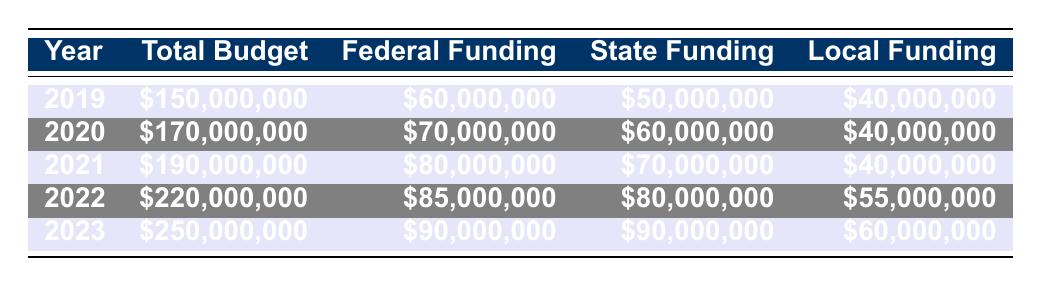What was the total budget for STEM programming in 2021? The table shows the total budget for each year listed. For 2021, the total budget is \$190,000,000.
Answer: \$190,000,000 What was the federal funding amount in 2023? According to the table, the federal funding for the year 2023 is listed as \$90,000,000.
Answer: \$90,000,000 Which year had the lowest local funding? By examining the local funding values in the table, the lowest local funding is in 2019, which is \$40,000,000.
Answer: 2019 What is the difference between federal funding in 2022 and 2021? The federal funding for 2022 is \$85,000,000 and for 2021 is \$80,000,000. The difference is \$85,000,000 - \$80,000,000 = \$5,000,000.
Answer: \$5,000,000 What is the average total budget over the five years? The total budgets for the five years are \$150,000,000, \$170,000,000, \$190,000,000, \$220,000,000, and \$250,000,000. Adding these gives \$1,080,000,000. Dividing by 5 gives an average of \$216,000,000.
Answer: \$216,000,000 Has federal funding increased every year? By comparing federal funding amounts from 2019 to 2023 in the table: \$60,000,000 (2019), \$70,000,000 (2020), \$80,000,000 (2021), \$85,000,000 (2022), and \$90,000,000 (2023), we see an increase each year. Therefore, the statement is true.
Answer: Yes Which funding source had the highest amount in 2020? In 2020, the funding amounts are federal: \$70,000,000, state: \$60,000,000, and local: \$40,000,000. The highest among these is the federal funding of \$70,000,000.
Answer: Federal Funding What is the percentage increase in the total budget from 2019 to 2023? The total budget in 2019 is \$150,000,000 and in 2023 is \$250,000,000. The increase is \$250,000,000 - \$150,000,000 = \$100,000,000. The percentage increase is (\$100,000,000 / \$150,000,000) * 100 = 66.67%.
Answer: 66.67% What is the local funding for 2022 and how does it compare to federal funding in the same year? The local funding for 2022 is \$55,000,000 and federal funding is \$85,000,000. Comparing these, \$85,000,000 is greater than \$55,000,000.
Answer: Federal funding is higher Is the state funding in 2021 more than the total local funding for that year? The state funding for 2021 is \$70,000,000 while local funding is \$40,000,000. Since \$70,000,000 > \$40,000,000, the statement is true.
Answer: Yes 